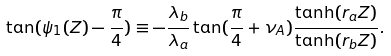<formula> <loc_0><loc_0><loc_500><loc_500>\tan ( \psi _ { 1 } ( Z ) - \frac { \pi } { 4 } ) \equiv - \frac { \lambda _ { b } } { \lambda _ { a } } \tan ( \frac { \pi } { 4 } + \nu _ { A } ) \frac { \tanh ( r _ { a } Z ) } { \tanh ( r _ { b } Z ) } .</formula> 